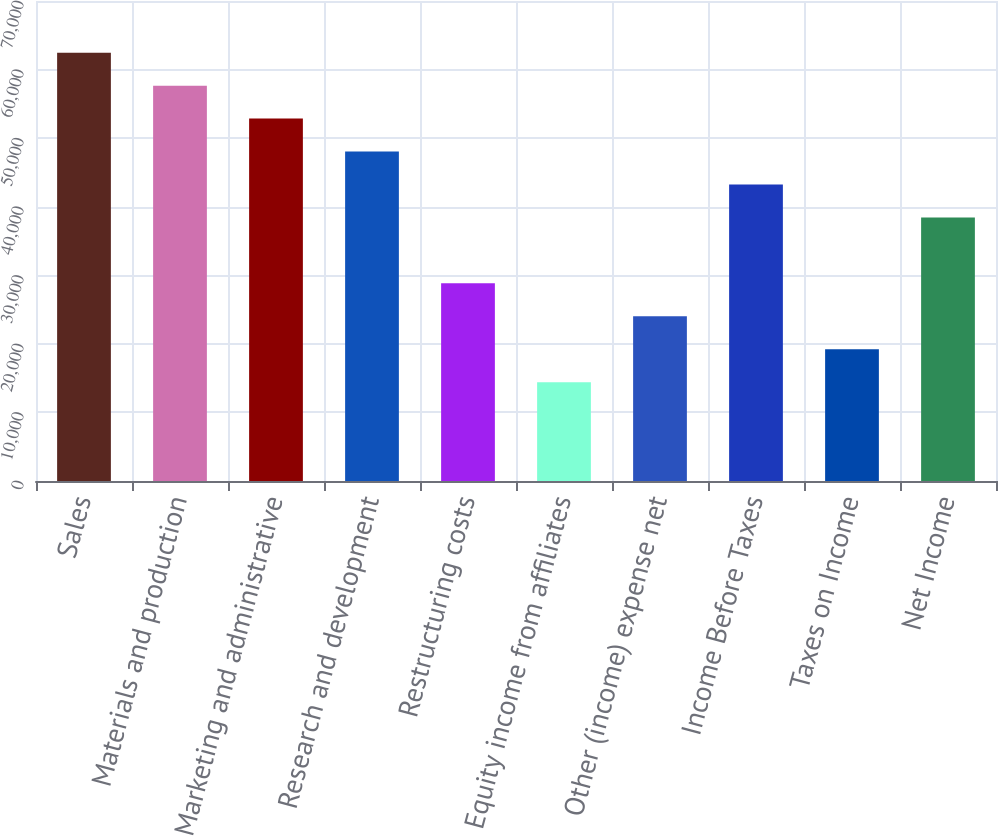<chart> <loc_0><loc_0><loc_500><loc_500><bar_chart><fcel>Sales<fcel>Materials and production<fcel>Marketing and administrative<fcel>Research and development<fcel>Restructuring costs<fcel>Equity income from affiliates<fcel>Other (income) expense net<fcel>Income Before Taxes<fcel>Taxes on Income<fcel>Net Income<nl><fcel>62460.5<fcel>57656<fcel>52851.5<fcel>48047<fcel>28829<fcel>14415.5<fcel>24024.5<fcel>43242.5<fcel>19220<fcel>38438<nl></chart> 